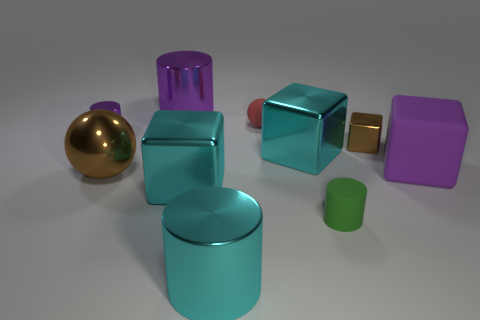What number of other objects are there of the same material as the small purple cylinder?
Your answer should be compact. 6. What is the color of the block that is to the left of the green cylinder and on the right side of the big cyan cylinder?
Provide a short and direct response. Cyan. Does the small sphere behind the big cyan metal cylinder have the same material as the tiny cylinder behind the purple block?
Your answer should be compact. No. Does the brown shiny object that is behind the purple block have the same size as the small red ball?
Provide a short and direct response. Yes. There is a large matte block; does it have the same color as the big shiny thing behind the small block?
Provide a succinct answer. Yes. What shape is the small thing that is the same color as the big rubber block?
Provide a succinct answer. Cylinder. The purple rubber thing has what shape?
Keep it short and to the point. Cube. Do the big sphere and the small cube have the same color?
Keep it short and to the point. Yes. What number of things are either metallic blocks that are in front of the big rubber block or tiny green metallic balls?
Your answer should be very brief. 1. There is a cube that is made of the same material as the tiny red sphere; what is its size?
Ensure brevity in your answer.  Large. 